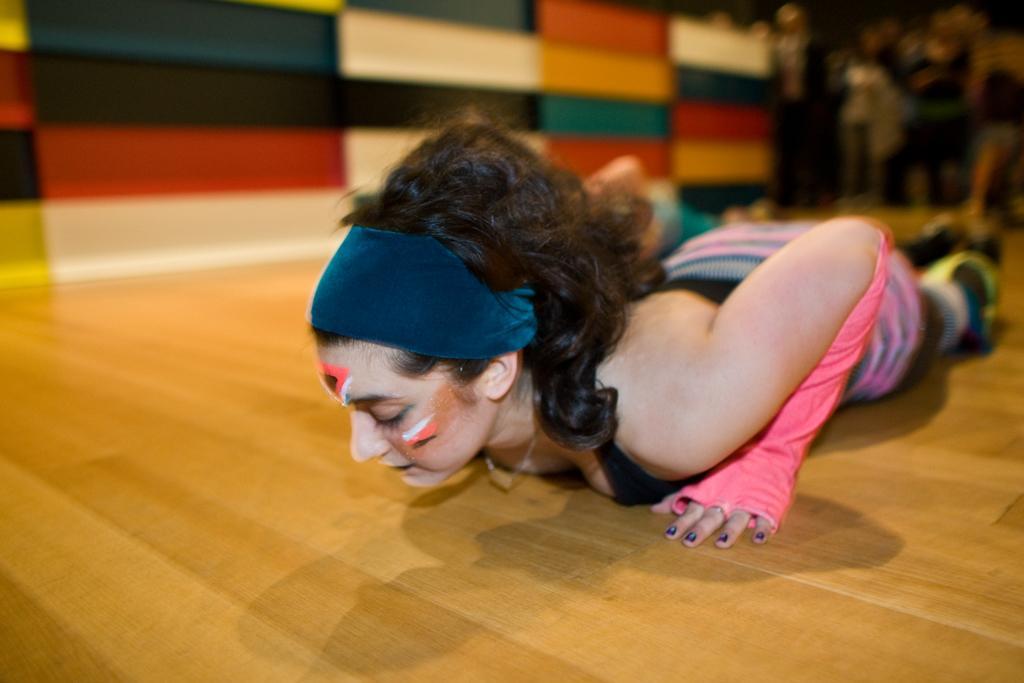How would you summarize this image in a sentence or two? There is a lady wearing headband and gloves is lying on the floor. In the background it is blurred. 